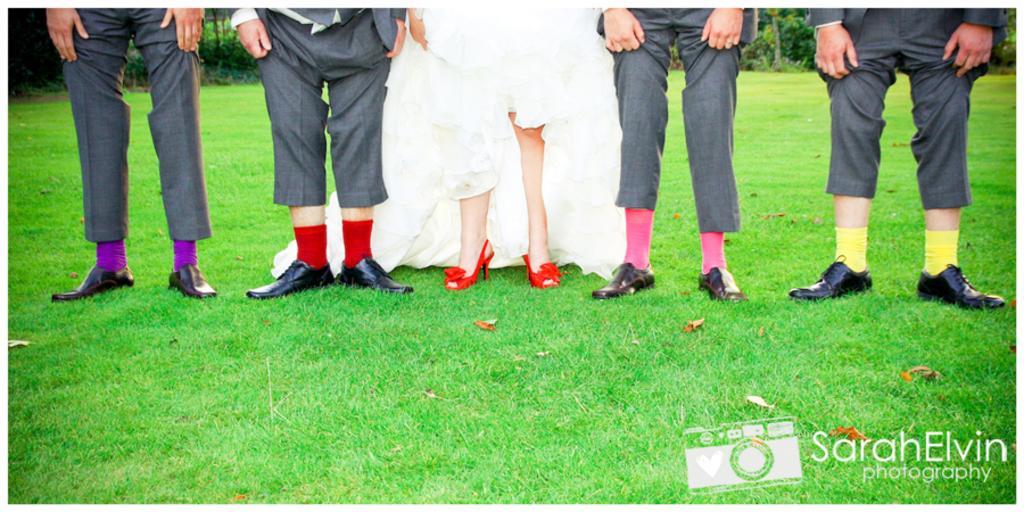How would you summarize this image in a sentence or two? In the foreground of the picture there are dry leaves and grass. In the center of the picture there are people's legs. In the background there are plants and trees. 